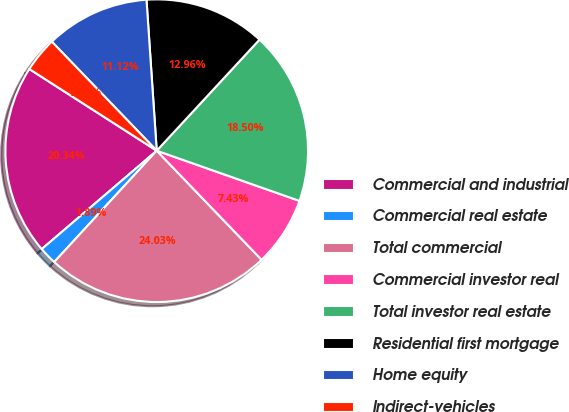Convert chart to OTSL. <chart><loc_0><loc_0><loc_500><loc_500><pie_chart><fcel>Commercial and industrial<fcel>Commercial real estate<fcel>Total commercial<fcel>Commercial investor real<fcel>Total investor real estate<fcel>Residential first mortgage<fcel>Home equity<fcel>Indirect-vehicles<nl><fcel>20.34%<fcel>1.89%<fcel>24.03%<fcel>7.43%<fcel>18.5%<fcel>12.96%<fcel>11.12%<fcel>3.73%<nl></chart> 